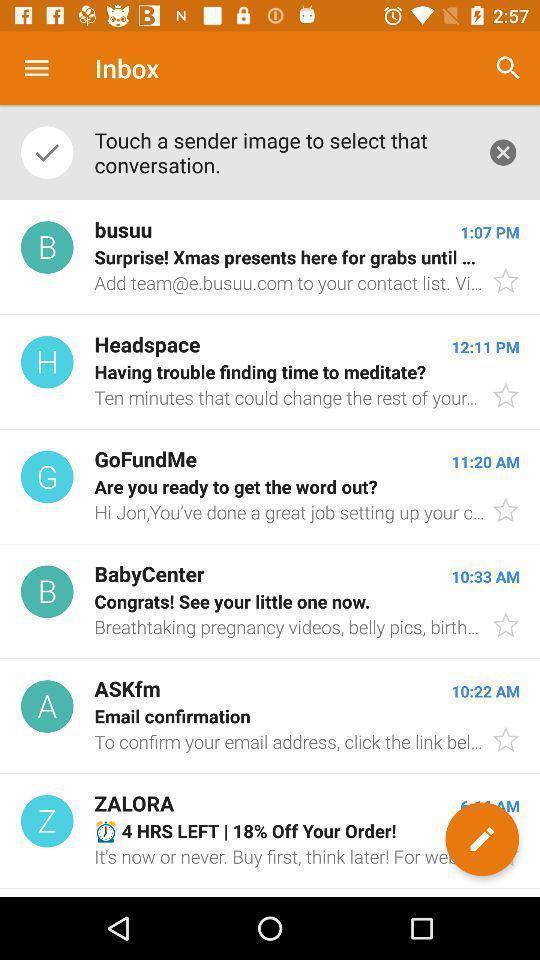Please provide a description for this image. Screen showing different type of mails. 